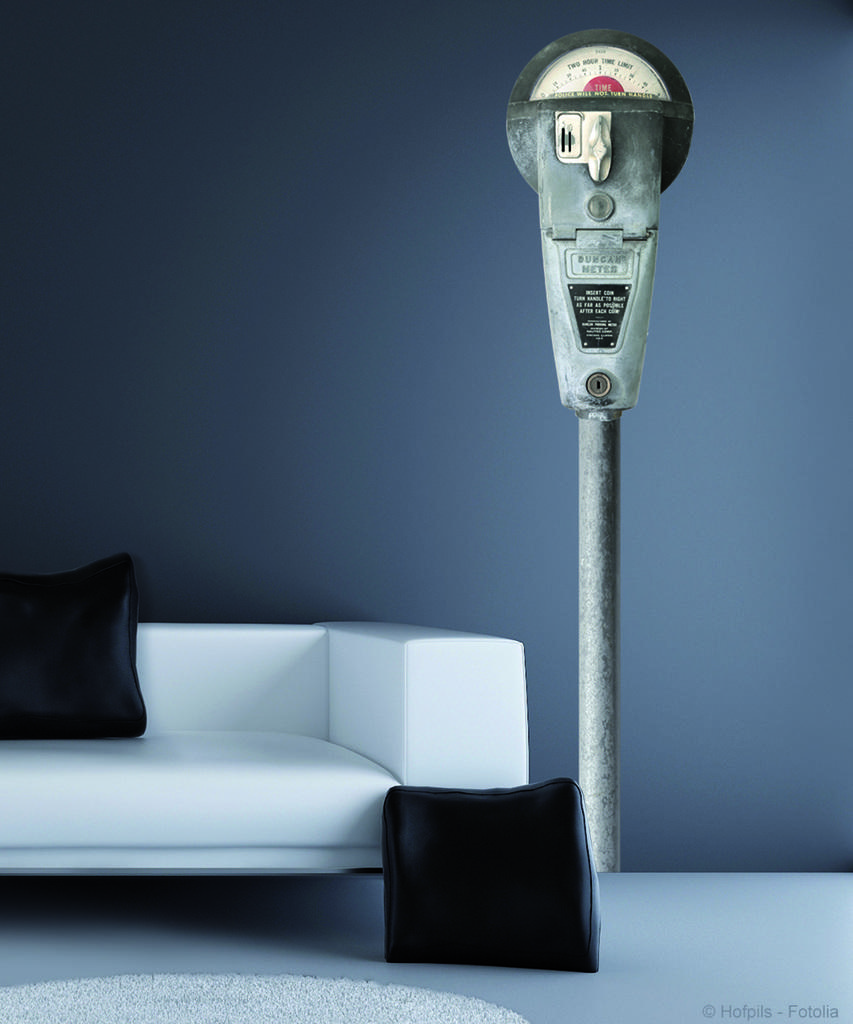What type of furniture is in the image? There is a sofa in the image. How many cushions are on the sofa? There are two cushions on the sofa. What color are the cushions? The cushions are black. What celestial object can be seen in the image? There is a meteor visible in the image. What type of pets are sitting on the sofa in the image? There are no pets visible in the image; it only shows a sofa with two black cushions. Are there any boats in the image? There are no boats present in the image. 